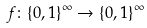<formula> <loc_0><loc_0><loc_500><loc_500>f \colon \{ 0 , 1 \} ^ { \infty } \to \{ 0 , 1 \} ^ { \infty }</formula> 